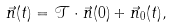Convert formula to latex. <formula><loc_0><loc_0><loc_500><loc_500>\vec { n } ( t ) = \mathcal { T } \cdot \vec { n } ( 0 ) + \vec { n } _ { 0 } ( t ) ,</formula> 